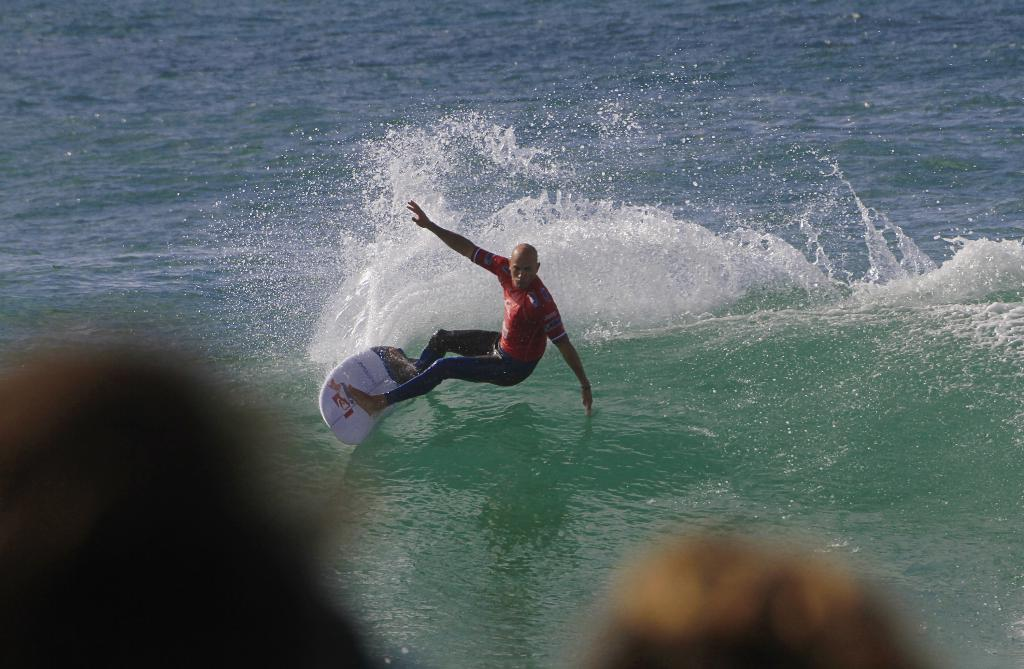What activity is the person in the image engaged in? The person is skiing in the image. Where is the person skiing? The person is skiing in the ocean. Can you tell if the image was taken during the day or night? The image is likely taken during the day. How many cows can be seen grazing in the ocean in the image? There are no cows present in the image; it features a person skiing in the ocean. 